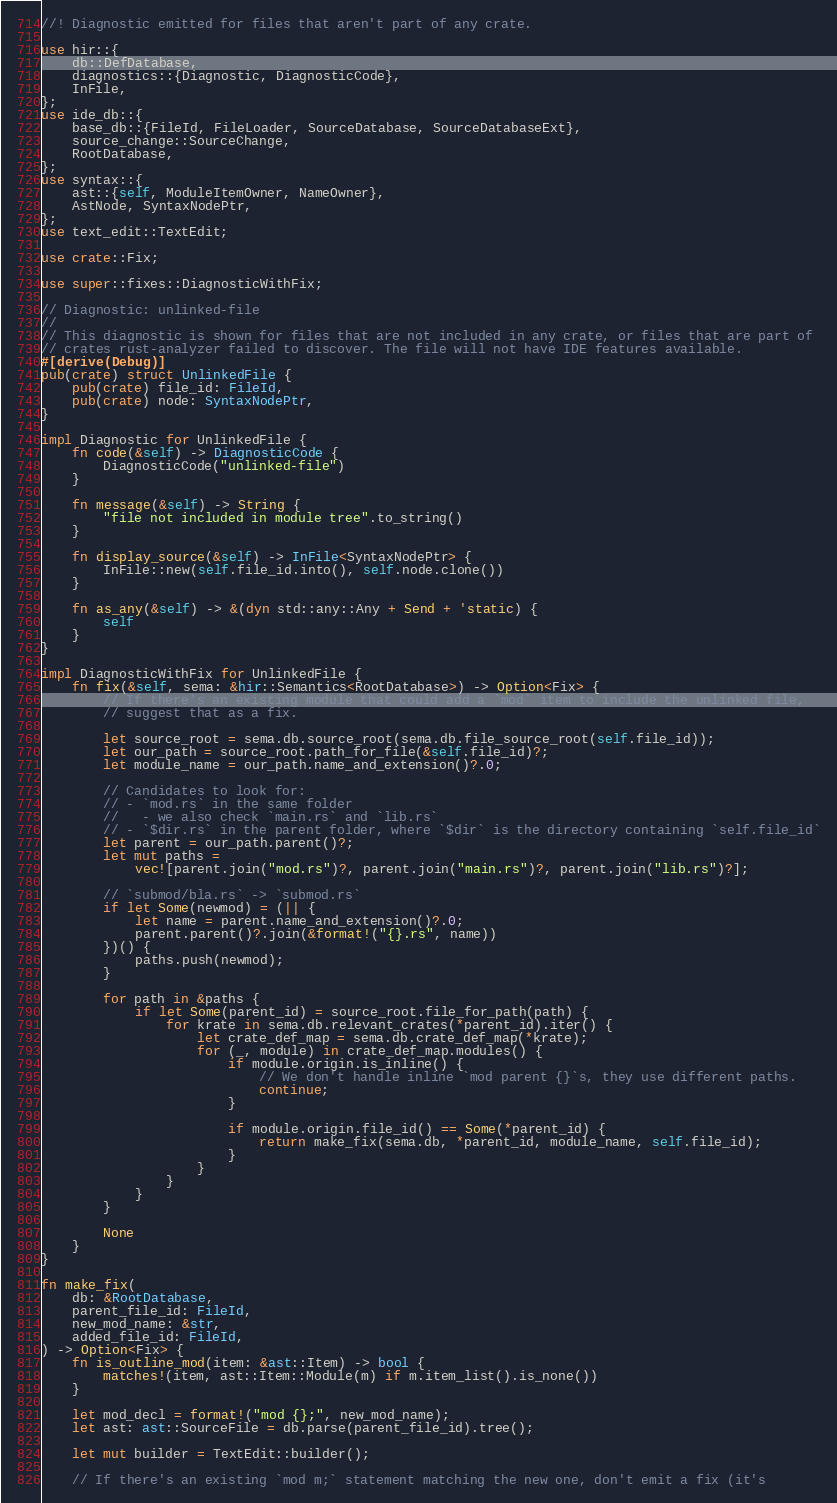<code> <loc_0><loc_0><loc_500><loc_500><_Rust_>//! Diagnostic emitted for files that aren't part of any crate.

use hir::{
    db::DefDatabase,
    diagnostics::{Diagnostic, DiagnosticCode},
    InFile,
};
use ide_db::{
    base_db::{FileId, FileLoader, SourceDatabase, SourceDatabaseExt},
    source_change::SourceChange,
    RootDatabase,
};
use syntax::{
    ast::{self, ModuleItemOwner, NameOwner},
    AstNode, SyntaxNodePtr,
};
use text_edit::TextEdit;

use crate::Fix;

use super::fixes::DiagnosticWithFix;

// Diagnostic: unlinked-file
//
// This diagnostic is shown for files that are not included in any crate, or files that are part of
// crates rust-analyzer failed to discover. The file will not have IDE features available.
#[derive(Debug)]
pub(crate) struct UnlinkedFile {
    pub(crate) file_id: FileId,
    pub(crate) node: SyntaxNodePtr,
}

impl Diagnostic for UnlinkedFile {
    fn code(&self) -> DiagnosticCode {
        DiagnosticCode("unlinked-file")
    }

    fn message(&self) -> String {
        "file not included in module tree".to_string()
    }

    fn display_source(&self) -> InFile<SyntaxNodePtr> {
        InFile::new(self.file_id.into(), self.node.clone())
    }

    fn as_any(&self) -> &(dyn std::any::Any + Send + 'static) {
        self
    }
}

impl DiagnosticWithFix for UnlinkedFile {
    fn fix(&self, sema: &hir::Semantics<RootDatabase>) -> Option<Fix> {
        // If there's an existing module that could add a `mod` item to include the unlinked file,
        // suggest that as a fix.

        let source_root = sema.db.source_root(sema.db.file_source_root(self.file_id));
        let our_path = source_root.path_for_file(&self.file_id)?;
        let module_name = our_path.name_and_extension()?.0;

        // Candidates to look for:
        // - `mod.rs` in the same folder
        //   - we also check `main.rs` and `lib.rs`
        // - `$dir.rs` in the parent folder, where `$dir` is the directory containing `self.file_id`
        let parent = our_path.parent()?;
        let mut paths =
            vec![parent.join("mod.rs")?, parent.join("main.rs")?, parent.join("lib.rs")?];

        // `submod/bla.rs` -> `submod.rs`
        if let Some(newmod) = (|| {
            let name = parent.name_and_extension()?.0;
            parent.parent()?.join(&format!("{}.rs", name))
        })() {
            paths.push(newmod);
        }

        for path in &paths {
            if let Some(parent_id) = source_root.file_for_path(path) {
                for krate in sema.db.relevant_crates(*parent_id).iter() {
                    let crate_def_map = sema.db.crate_def_map(*krate);
                    for (_, module) in crate_def_map.modules() {
                        if module.origin.is_inline() {
                            // We don't handle inline `mod parent {}`s, they use different paths.
                            continue;
                        }

                        if module.origin.file_id() == Some(*parent_id) {
                            return make_fix(sema.db, *parent_id, module_name, self.file_id);
                        }
                    }
                }
            }
        }

        None
    }
}

fn make_fix(
    db: &RootDatabase,
    parent_file_id: FileId,
    new_mod_name: &str,
    added_file_id: FileId,
) -> Option<Fix> {
    fn is_outline_mod(item: &ast::Item) -> bool {
        matches!(item, ast::Item::Module(m) if m.item_list().is_none())
    }

    let mod_decl = format!("mod {};", new_mod_name);
    let ast: ast::SourceFile = db.parse(parent_file_id).tree();

    let mut builder = TextEdit::builder();

    // If there's an existing `mod m;` statement matching the new one, don't emit a fix (it's</code> 